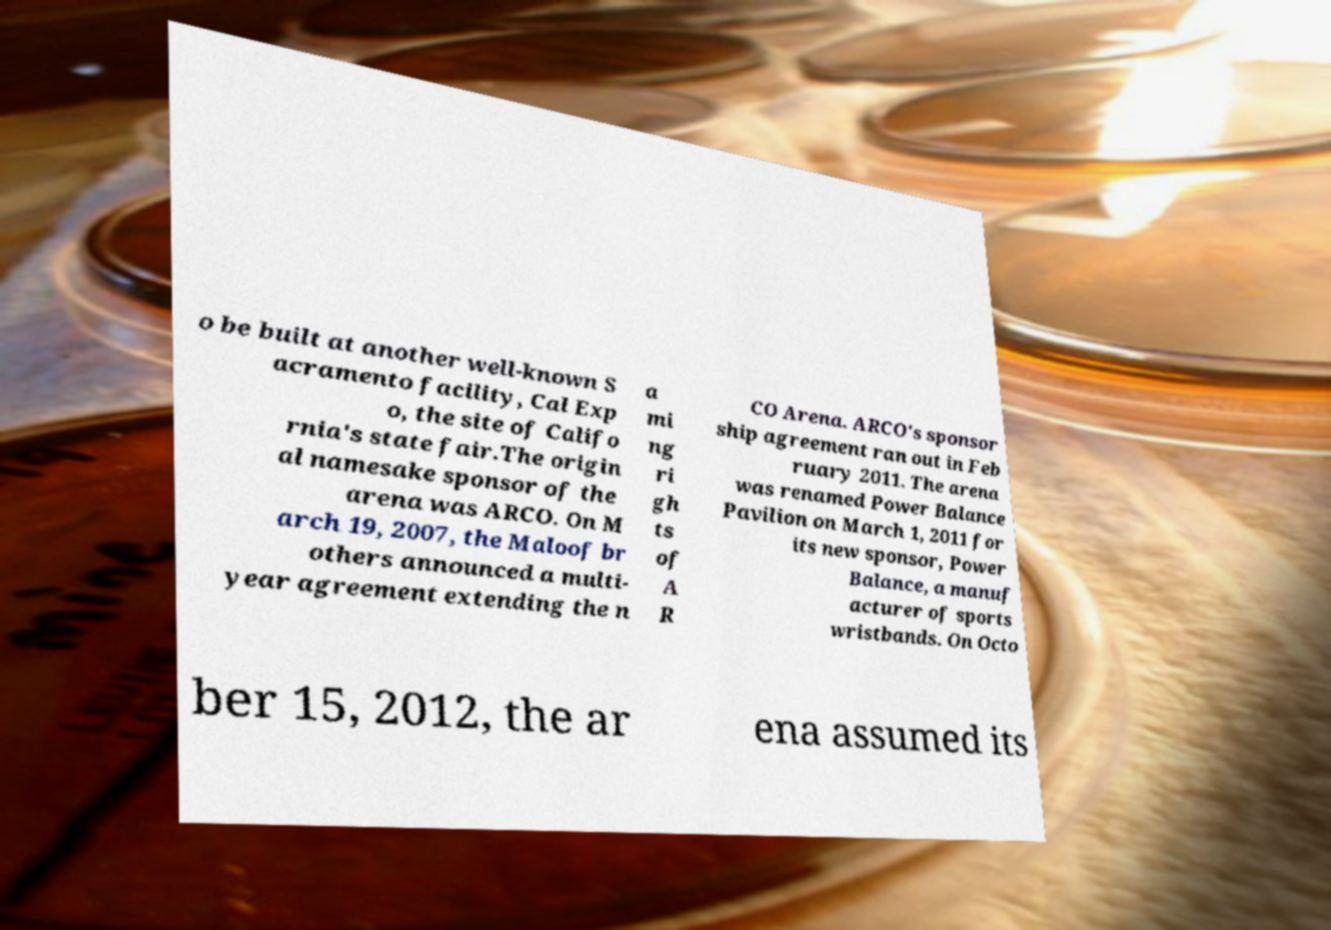I need the written content from this picture converted into text. Can you do that? o be built at another well-known S acramento facility, Cal Exp o, the site of Califo rnia's state fair.The origin al namesake sponsor of the arena was ARCO. On M arch 19, 2007, the Maloof br others announced a multi- year agreement extending the n a mi ng ri gh ts of A R CO Arena. ARCO's sponsor ship agreement ran out in Feb ruary 2011. The arena was renamed Power Balance Pavilion on March 1, 2011 for its new sponsor, Power Balance, a manuf acturer of sports wristbands. On Octo ber 15, 2012, the ar ena assumed its 